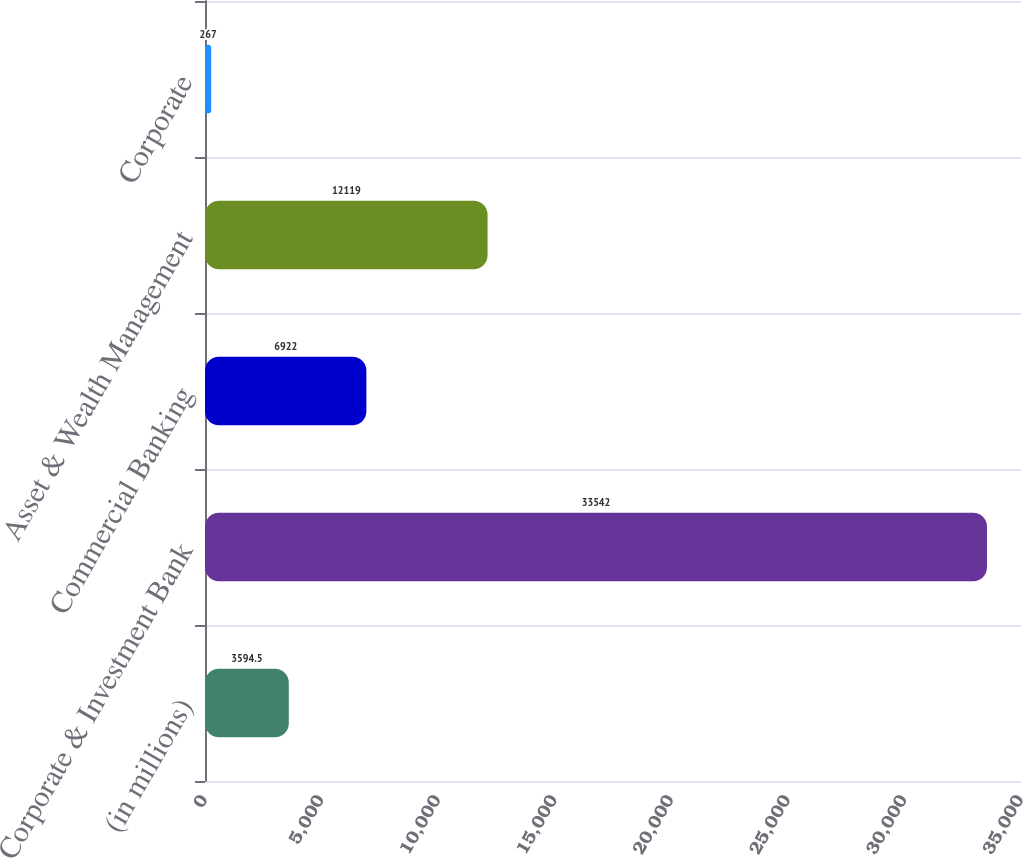Convert chart. <chart><loc_0><loc_0><loc_500><loc_500><bar_chart><fcel>(in millions)<fcel>Corporate & Investment Bank<fcel>Commercial Banking<fcel>Asset & Wealth Management<fcel>Corporate<nl><fcel>3594.5<fcel>33542<fcel>6922<fcel>12119<fcel>267<nl></chart> 